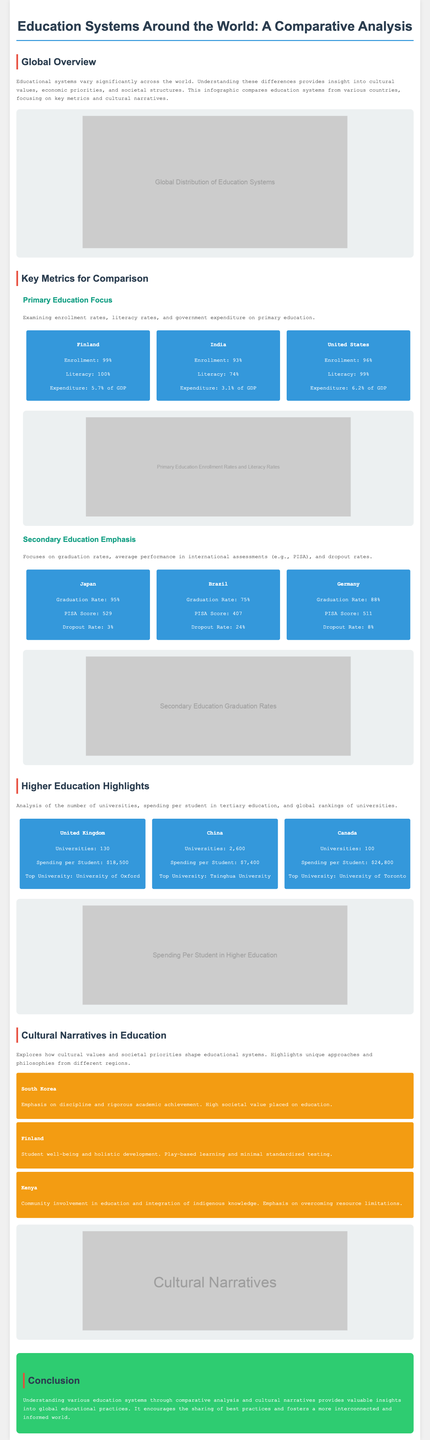What is the primary school enrollment rate in Finland? The enrollment rate in Finland is provided as a key metric in the document, which states it is 99%.
Answer: 99% What is Japan's PISA score? The PISA score for Japan is listed in the secondary education metrics section, specifically as 529.
Answer: 529 How many universities are there in China? The number of universities in China is given, which is 2,600.
Answer: 2,600 What is the dropout rate in Brazil? The dropout rate for Brazil is included in the secondary education section, which states it is 24%.
Answer: 24% What cultural narrative emphasizes student well-being? In the cultural narratives section, Finland's approach is described with an emphasis on student well-being and holistic development.
Answer: Finland Which country has the highest spending per student in higher education? The spending per student in Canada is highlighted as the highest at $24,800.
Answer: $24,800 What percentage of GDP does India spend on primary education? India's expenditure on primary education is given as 3.1% of GDP in the document.
Answer: 3.1% Which country is noted for focusing on community involvement in education? Kenya is highlighted in the cultural narratives section for its community involvement in education.
Answer: Kenya What is the graduation rate in Germany? The document lists Germany's graduation rate in secondary education as 88%.
Answer: 88% 